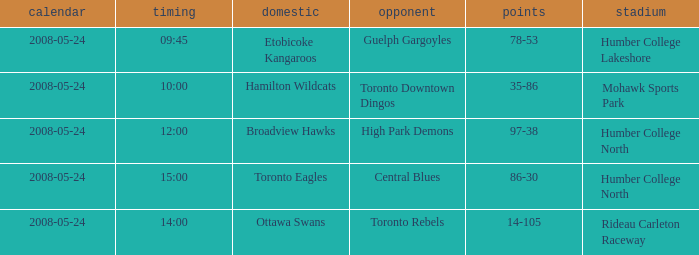Who was the home team of the game at the time of 15:00? Toronto Eagles. 